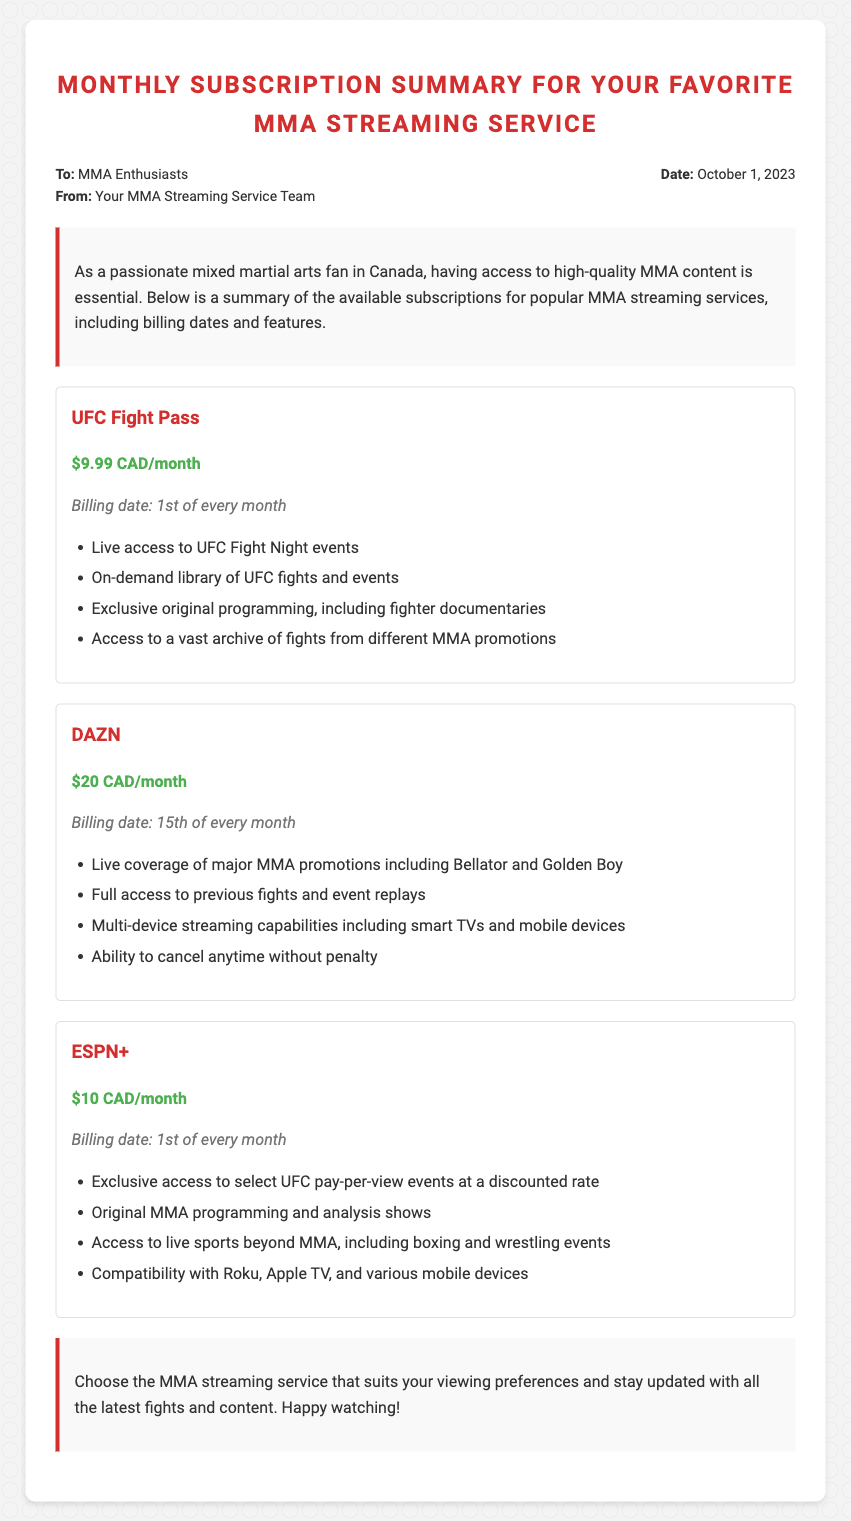What is the billing date for UFC Fight Pass? The document specifies that UFC Fight Pass has a billing date of the 1st of every month.
Answer: 1st of every month How much does DAZN cost per month? The monthly cost for DAZN is listed as $20 CAD.
Answer: $20 CAD/month What is included in the ESPN+ subscription? The document lists several features of ESPN+, including access to select UFC pay-per-view events and original programming.
Answer: Exclusive access to select UFC pay-per-view events at a discounted rate What are the streaming options for DAZN? The document mentions that DAZN offers multi-device streaming capabilities including smart TVs and mobile devices.
Answer: Multi-device streaming capabilities How often is the billing date for ESPN+? The billing date for ESPN+ is indicated as the 1st of every month, similar to UFC Fight Pass.
Answer: 1st of every month What is the monthly price for UFC Fight Pass? The document states the price of UFC Fight Pass is $9.99 CAD/month.
Answer: $9.99 CAD/month Which service has exclusive original programming? The document notes that UFC Fight Pass provides exclusive original programming, including fighter documentaries.
Answer: UFC Fight Pass Is there a cancellation penalty for DAZN? The document explicitly states that DAZN allows the ability to cancel anytime without penalty.
Answer: No What is the purpose of the document? The document serves as a summary of available subscriptions for popular MMA streaming services along with billing dates and features.
Answer: Monthly Subscription Summary 